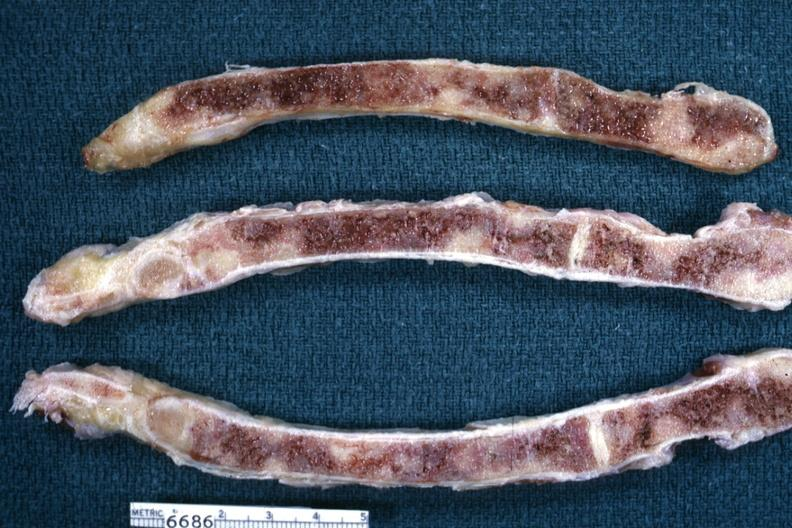does this image show sections of sternum with metastatic lesions from breast?
Answer the question using a single word or phrase. Yes 